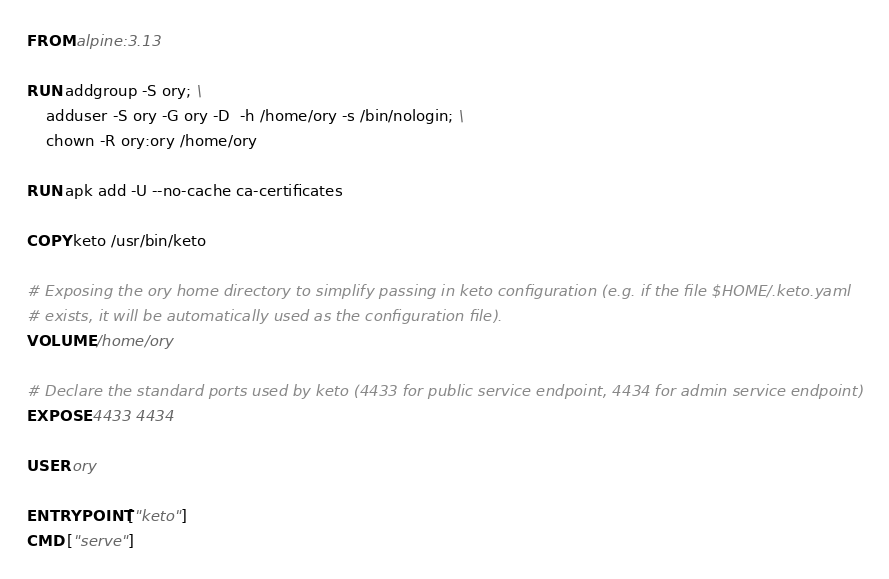<code> <loc_0><loc_0><loc_500><loc_500><_Dockerfile_>FROM alpine:3.13

RUN addgroup -S ory; \
    adduser -S ory -G ory -D  -h /home/ory -s /bin/nologin; \
    chown -R ory:ory /home/ory

RUN apk add -U --no-cache ca-certificates

COPY keto /usr/bin/keto

# Exposing the ory home directory to simplify passing in keto configuration (e.g. if the file $HOME/.keto.yaml
# exists, it will be automatically used as the configuration file).
VOLUME /home/ory

# Declare the standard ports used by keto (4433 for public service endpoint, 4434 for admin service endpoint)
EXPOSE 4433 4434

USER ory

ENTRYPOINT ["keto"]
CMD ["serve"]
</code> 